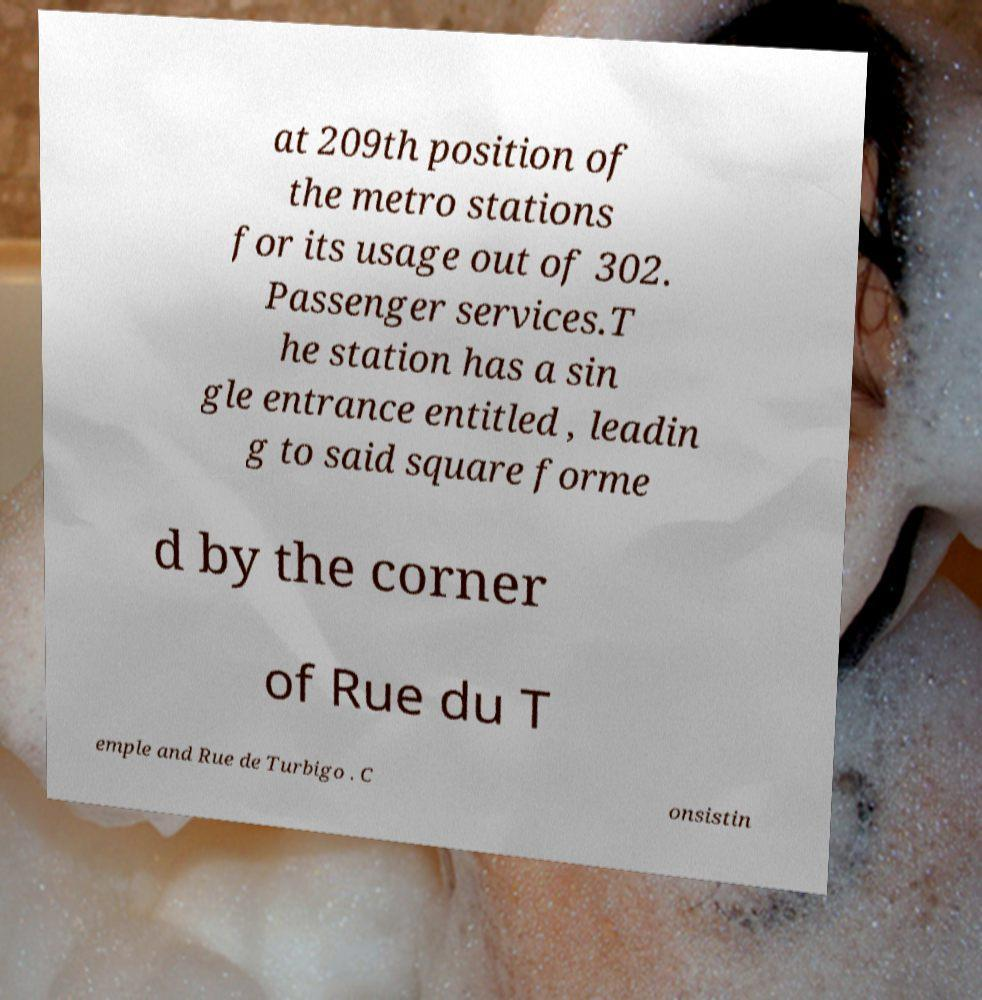For documentation purposes, I need the text within this image transcribed. Could you provide that? at 209th position of the metro stations for its usage out of 302. Passenger services.T he station has a sin gle entrance entitled , leadin g to said square forme d by the corner of Rue du T emple and Rue de Turbigo . C onsistin 